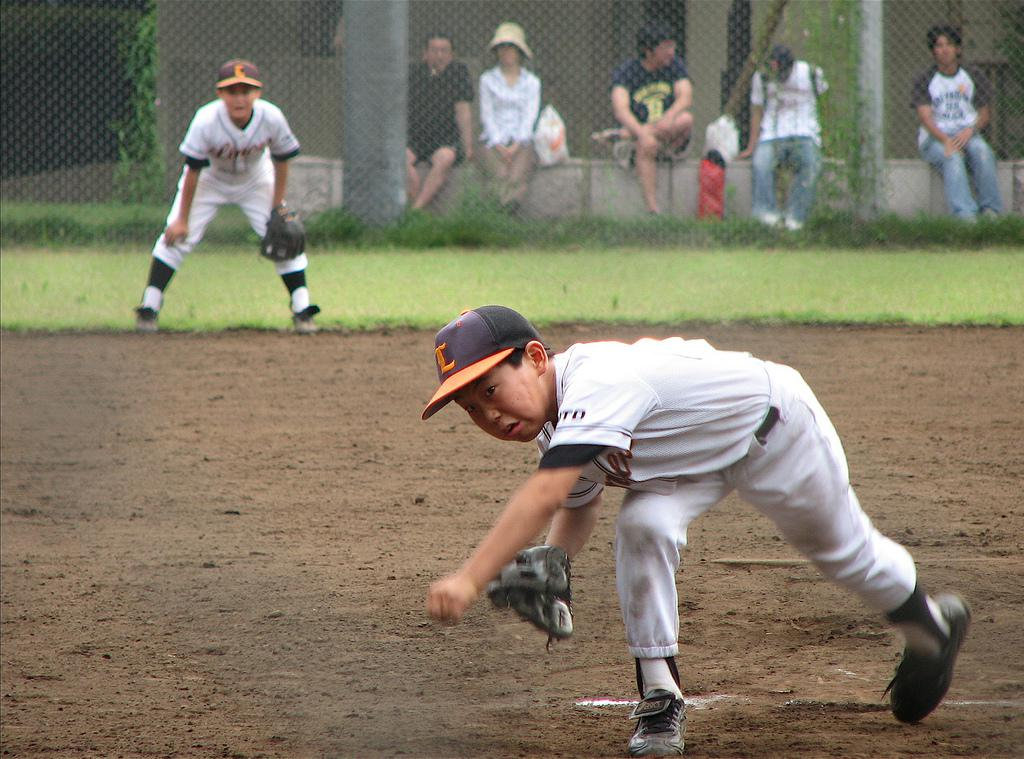Question: where is he throwing the ball?
Choices:
A. Over the net.
B. Into the water.
C. On the baseball field.
D. To the pitcher.
Answer with the letter. Answer: C Question: when is the game over?
Choices:
A. After 9 innings.
B. Maybe sooner than later.
C. Probably early evening.
D. In about 30 minutes.
Answer with the letter. Answer: C Question: who is playing baseball?
Choices:
A. High school team.
B. The womens team.
C. Young kids.
D. The 5th grade class.
Answer with the letter. Answer: C Question: how was the lighting outside?
Choices:
A. Very bright.
B. Incredibly sunny.
C. It looked a little cloudy.
D. Dull due to overcast.
Answer with the letter. Answer: C Question: what color is the boys hat?
Choices:
A. Yellow and red.
B. Rainbow.
C. Black.
D. Brown and orange.
Answer with the letter. Answer: D Question: what does the boy in the outfield want to do?
Choices:
A. Catch a homerun.
B. Run.
C. Catch a ball.
D. Hit a ball.
Answer with the letter. Answer: C Question: what does the infield look like?
Choices:
A. Mud.
B. Grassy.
C. Turk.
D. Wet.
Answer with the letter. Answer: A Question: why is he so low?
Choices:
A. He is bowling.
B. He`s throwing the ball with all his might.
C. He is playing limbo.
D. He is looking for something.
Answer with the letter. Answer: B Question: who has on white uniforms?
Choices:
A. Four Referees.
B. Two players.
C. Six Spectators.
D. Three Cheerleaders.
Answer with the letter. Answer: B Question: where are people sitting?
Choices:
A. On lawn chairs.
B. On concrete benches.
C. On the ground.
D. On wooden benches.
Answer with the letter. Answer: B Question: where is the mitt?
Choices:
A. On the Boy's right hand.
B. On boy's left hand.
C. On the girl's left hand.
D. On the girl's right hand.
Answer with the letter. Answer: B Question: who wearing protective gear on his legs?
Choices:
A. A baseball player in the back.
B. A goalie near the net.
C. A hockey player in the center.
D. A pitcher on the mound.
Answer with the letter. Answer: A Question: how many people are watching?
Choices:
A. 5.
B. 1.
C. 2.
D. 3.
Answer with the letter. Answer: A Question: what are the players playing on?
Choices:
A. A meadow with a grass boundary.
B. A field with a grass border.
C. A pasture with a sod border.
D. A meadow with a sod boundary.
Answer with the letter. Answer: B Question: how does the boy look?
Choices:
A. Happy.
B. Sad.
C. Elated.
D. Distraught.
Answer with the letter. Answer: B 